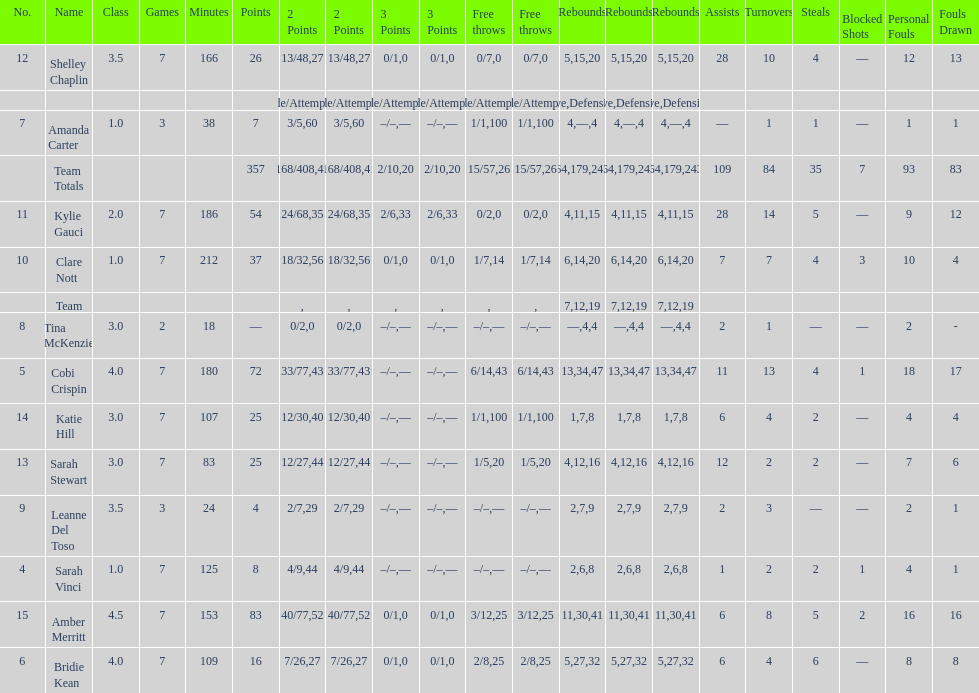Alongside merritt, who was the leading scorer? Cobi Crispin. 